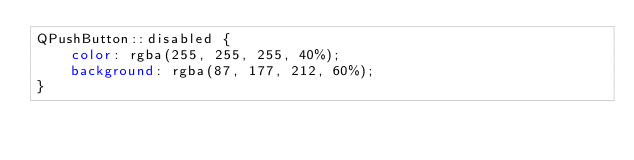Convert code to text. <code><loc_0><loc_0><loc_500><loc_500><_CSS_>QPushButton::disabled {
    color: rgba(255, 255, 255, 40%);
    background: rgba(87, 177, 212, 60%);
}
</code> 